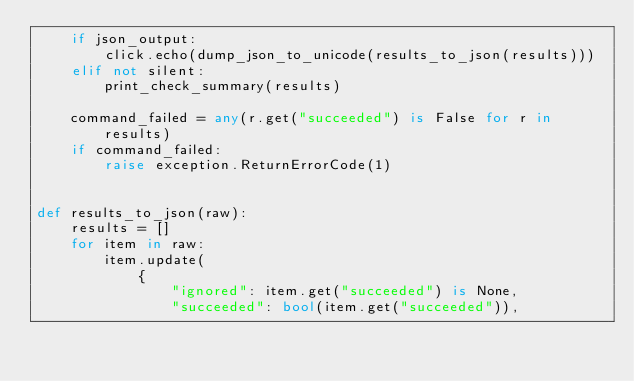Convert code to text. <code><loc_0><loc_0><loc_500><loc_500><_Python_>    if json_output:
        click.echo(dump_json_to_unicode(results_to_json(results)))
    elif not silent:
        print_check_summary(results)

    command_failed = any(r.get("succeeded") is False for r in results)
    if command_failed:
        raise exception.ReturnErrorCode(1)


def results_to_json(raw):
    results = []
    for item in raw:
        item.update(
            {
                "ignored": item.get("succeeded") is None,
                "succeeded": bool(item.get("succeeded")),</code> 